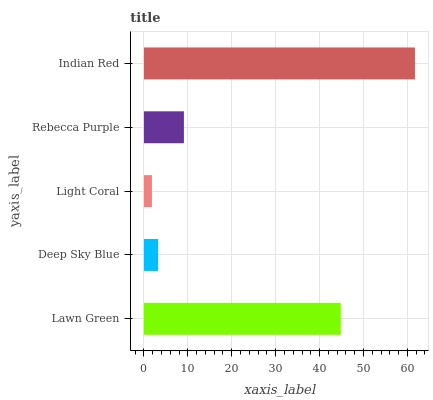Is Light Coral the minimum?
Answer yes or no. Yes. Is Indian Red the maximum?
Answer yes or no. Yes. Is Deep Sky Blue the minimum?
Answer yes or no. No. Is Deep Sky Blue the maximum?
Answer yes or no. No. Is Lawn Green greater than Deep Sky Blue?
Answer yes or no. Yes. Is Deep Sky Blue less than Lawn Green?
Answer yes or no. Yes. Is Deep Sky Blue greater than Lawn Green?
Answer yes or no. No. Is Lawn Green less than Deep Sky Blue?
Answer yes or no. No. Is Rebecca Purple the high median?
Answer yes or no. Yes. Is Rebecca Purple the low median?
Answer yes or no. Yes. Is Light Coral the high median?
Answer yes or no. No. Is Light Coral the low median?
Answer yes or no. No. 